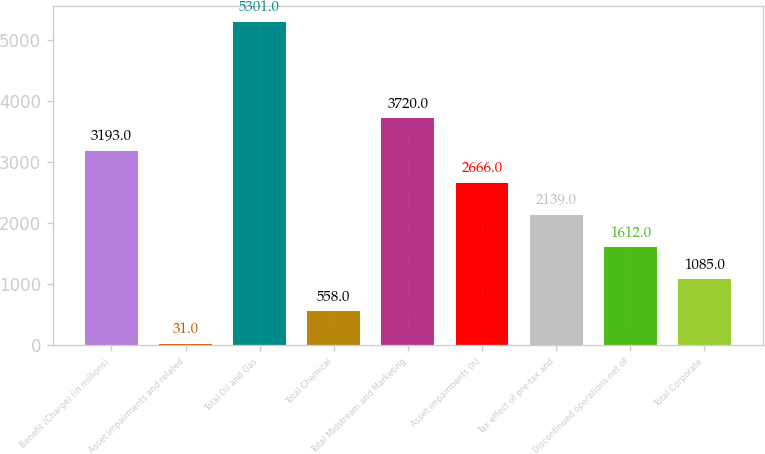Convert chart to OTSL. <chart><loc_0><loc_0><loc_500><loc_500><bar_chart><fcel>Benefit (Charge) (in millions)<fcel>Asset impairments and related<fcel>Total Oil and Gas<fcel>Total Chemical<fcel>Total Midstream and Marketing<fcel>Asset impairments (h)<fcel>Tax effect of pre-tax and<fcel>Discontinued operations net of<fcel>Total Corporate<nl><fcel>3193<fcel>31<fcel>5301<fcel>558<fcel>3720<fcel>2666<fcel>2139<fcel>1612<fcel>1085<nl></chart> 